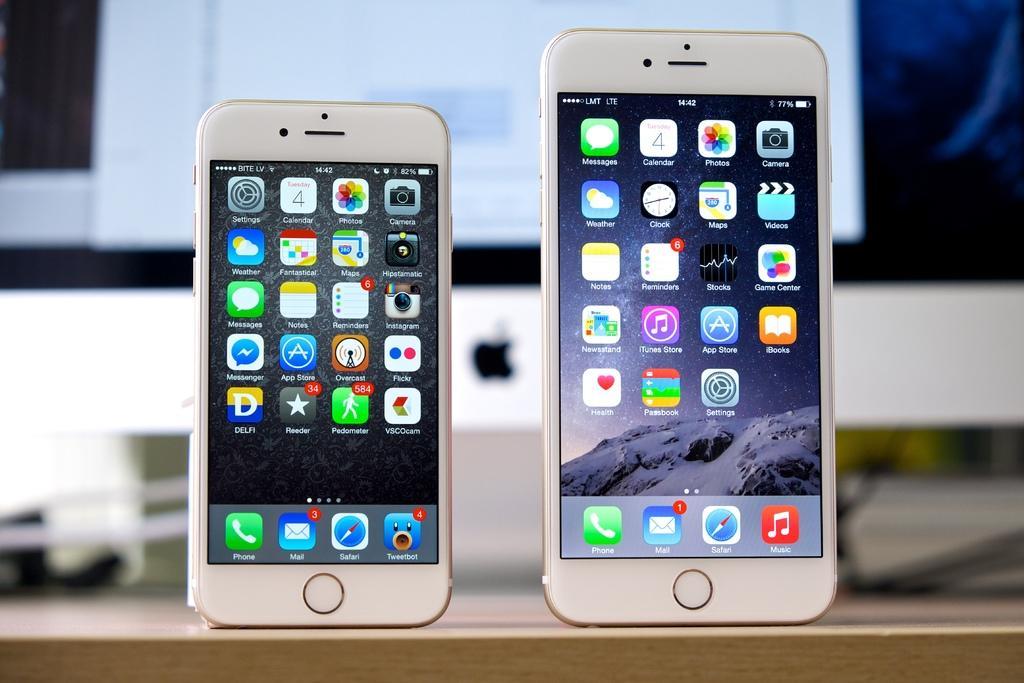Could you give a brief overview of what you see in this image? In this picture there are cell phones on the table. On the screens, there are icons and there is text. At the back there is a computer and there are wires. 